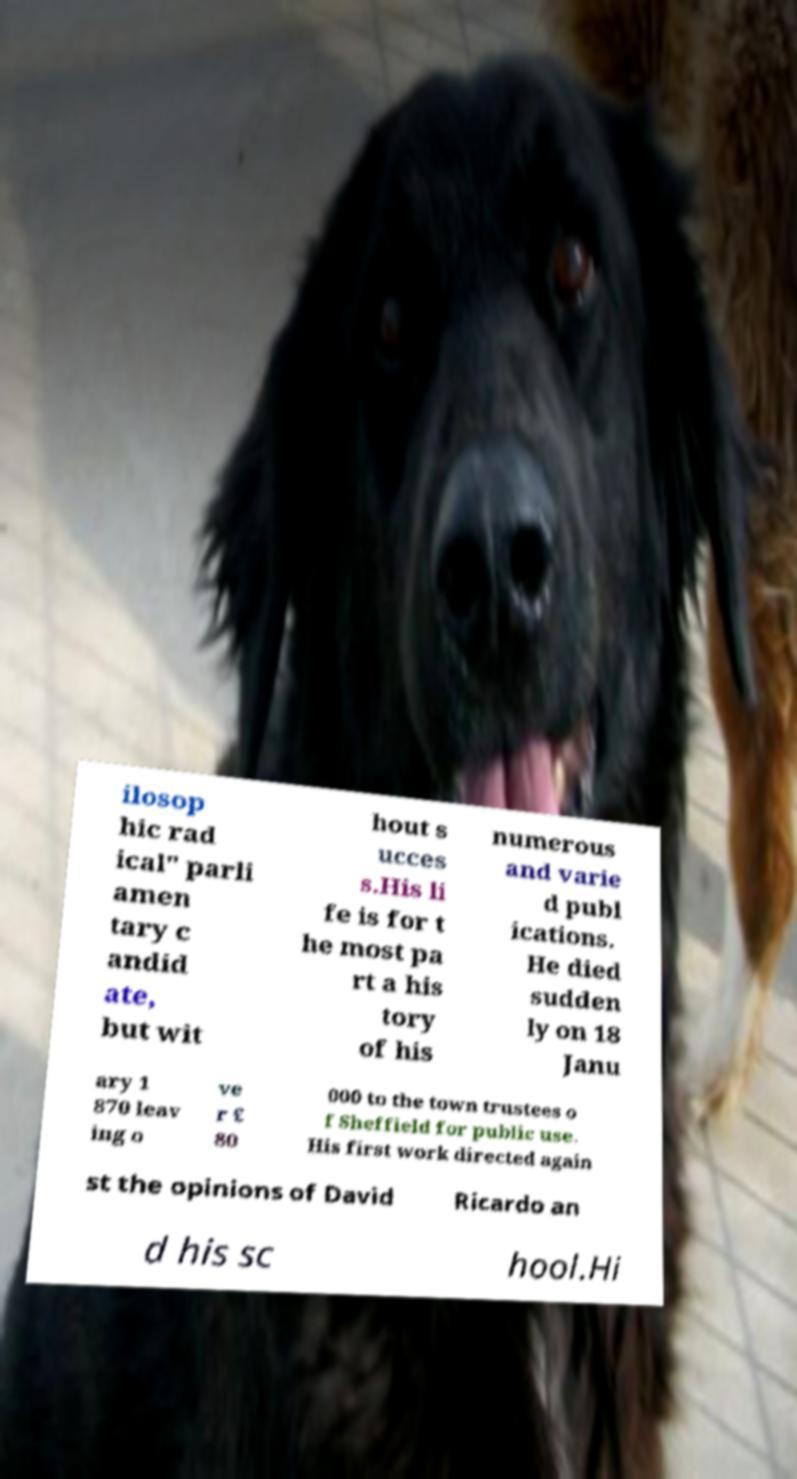What messages or text are displayed in this image? I need them in a readable, typed format. ilosop hic rad ical" parli amen tary c andid ate, but wit hout s ucces s.His li fe is for t he most pa rt a his tory of his numerous and varie d publ ications. He died sudden ly on 18 Janu ary 1 870 leav ing o ve r £ 80 000 to the town trustees o f Sheffield for public use. His first work directed again st the opinions of David Ricardo an d his sc hool.Hi 